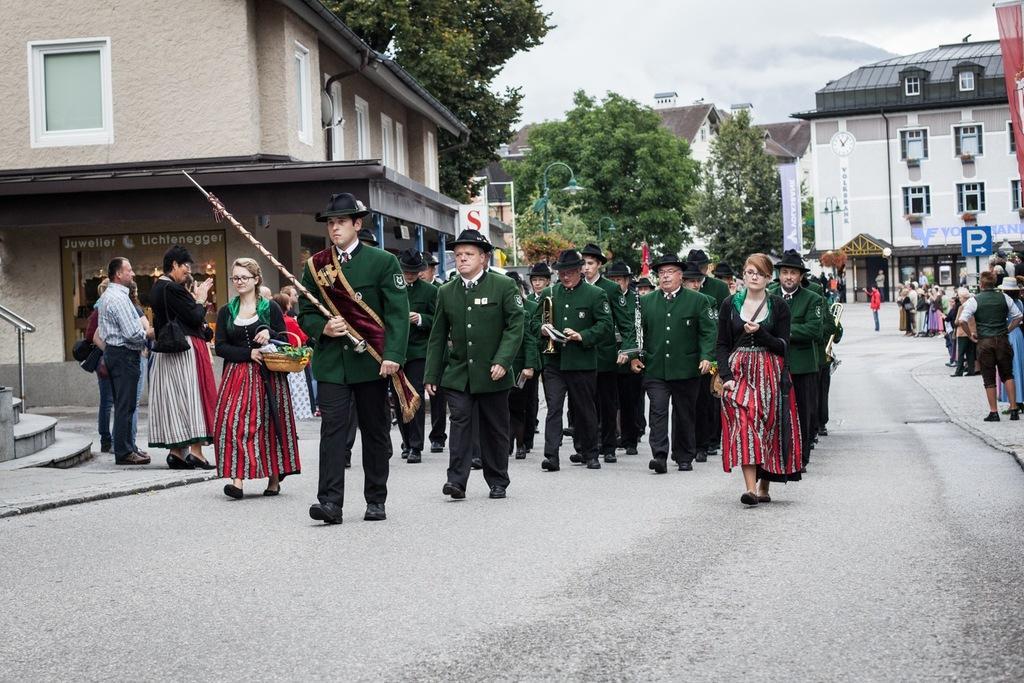Describe this image in one or two sentences. A group of men are walking on the road, they wore green color coats, trousers, hats. On the right side a beautiful woman is also walking. These are the houses and trees. 